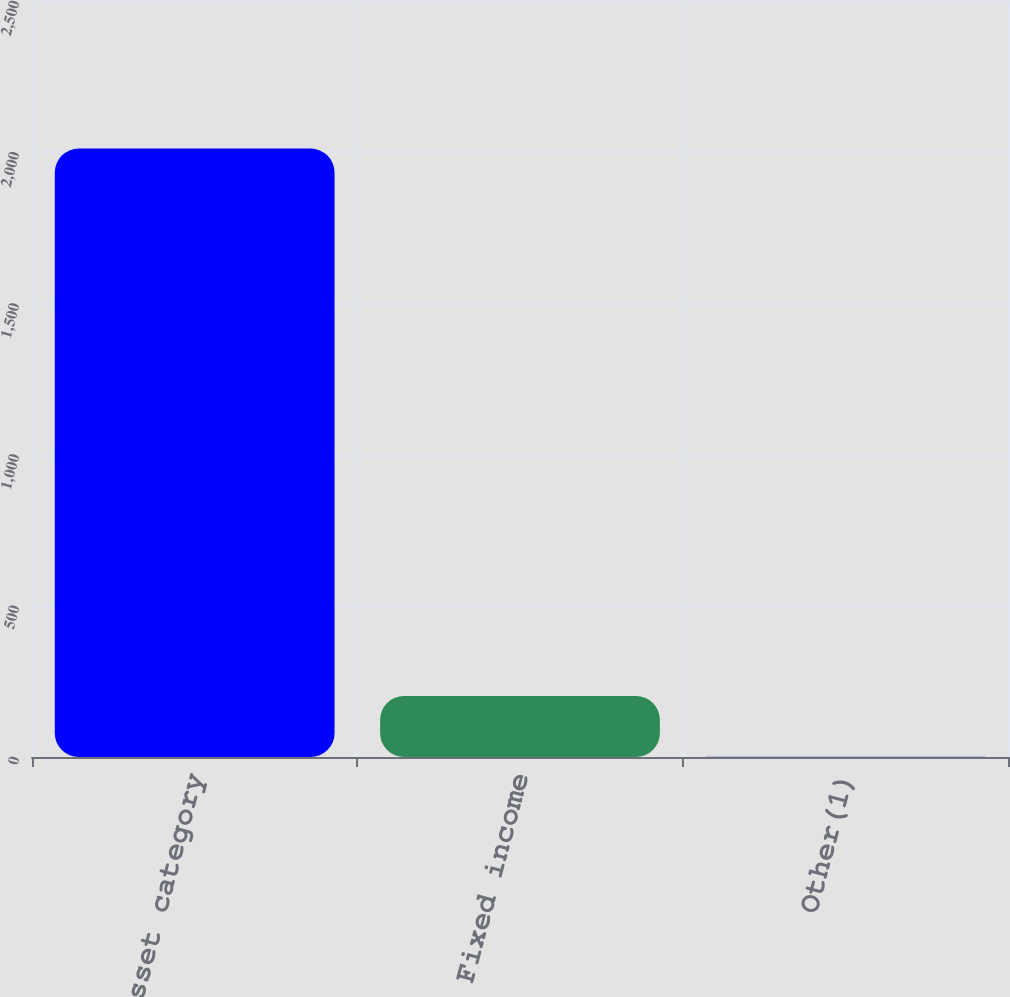Convert chart. <chart><loc_0><loc_0><loc_500><loc_500><bar_chart><fcel>Asset category<fcel>Fixed income<fcel>Other(1)<nl><fcel>2012<fcel>201.98<fcel>0.87<nl></chart> 